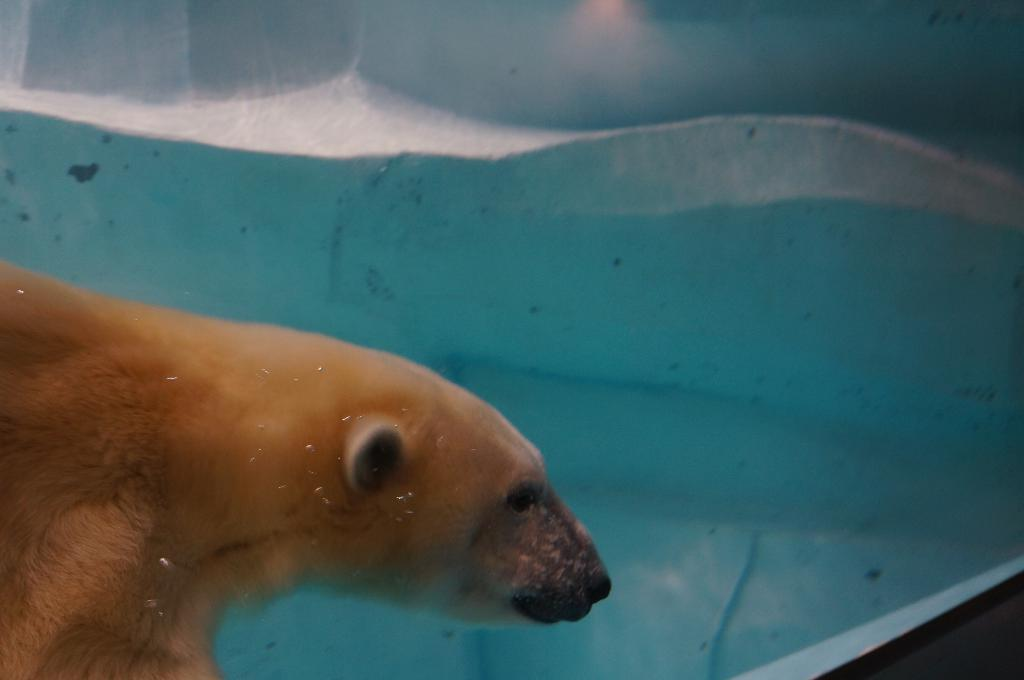What is the animal doing in the image? The animal is in the water. Can you describe any other elements in the image? There is a wall visible in the bottom right corner of the image. What type of night event is the animal attending in the image? There is no night event or attention-related activity depicted in the image; it simply shows an animal in the water and a wall in the corner. 